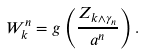Convert formula to latex. <formula><loc_0><loc_0><loc_500><loc_500>W ^ { n } _ { k } = g \left ( \frac { Z _ { k \wedge \gamma _ { n } } } { a ^ { n } } \right ) .</formula> 